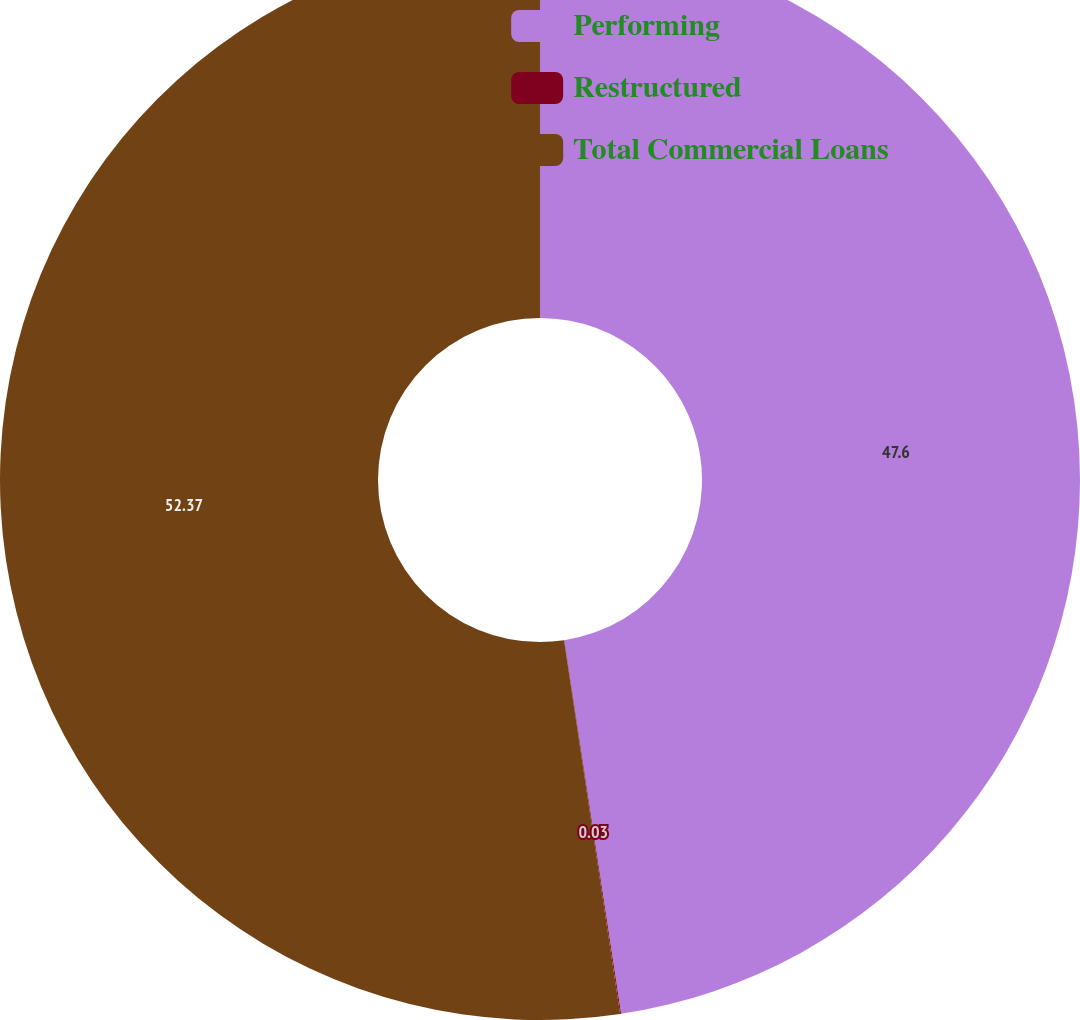Convert chart to OTSL. <chart><loc_0><loc_0><loc_500><loc_500><pie_chart><fcel>Performing<fcel>Restructured<fcel>Total Commercial Loans<nl><fcel>47.6%<fcel>0.03%<fcel>52.37%<nl></chart> 